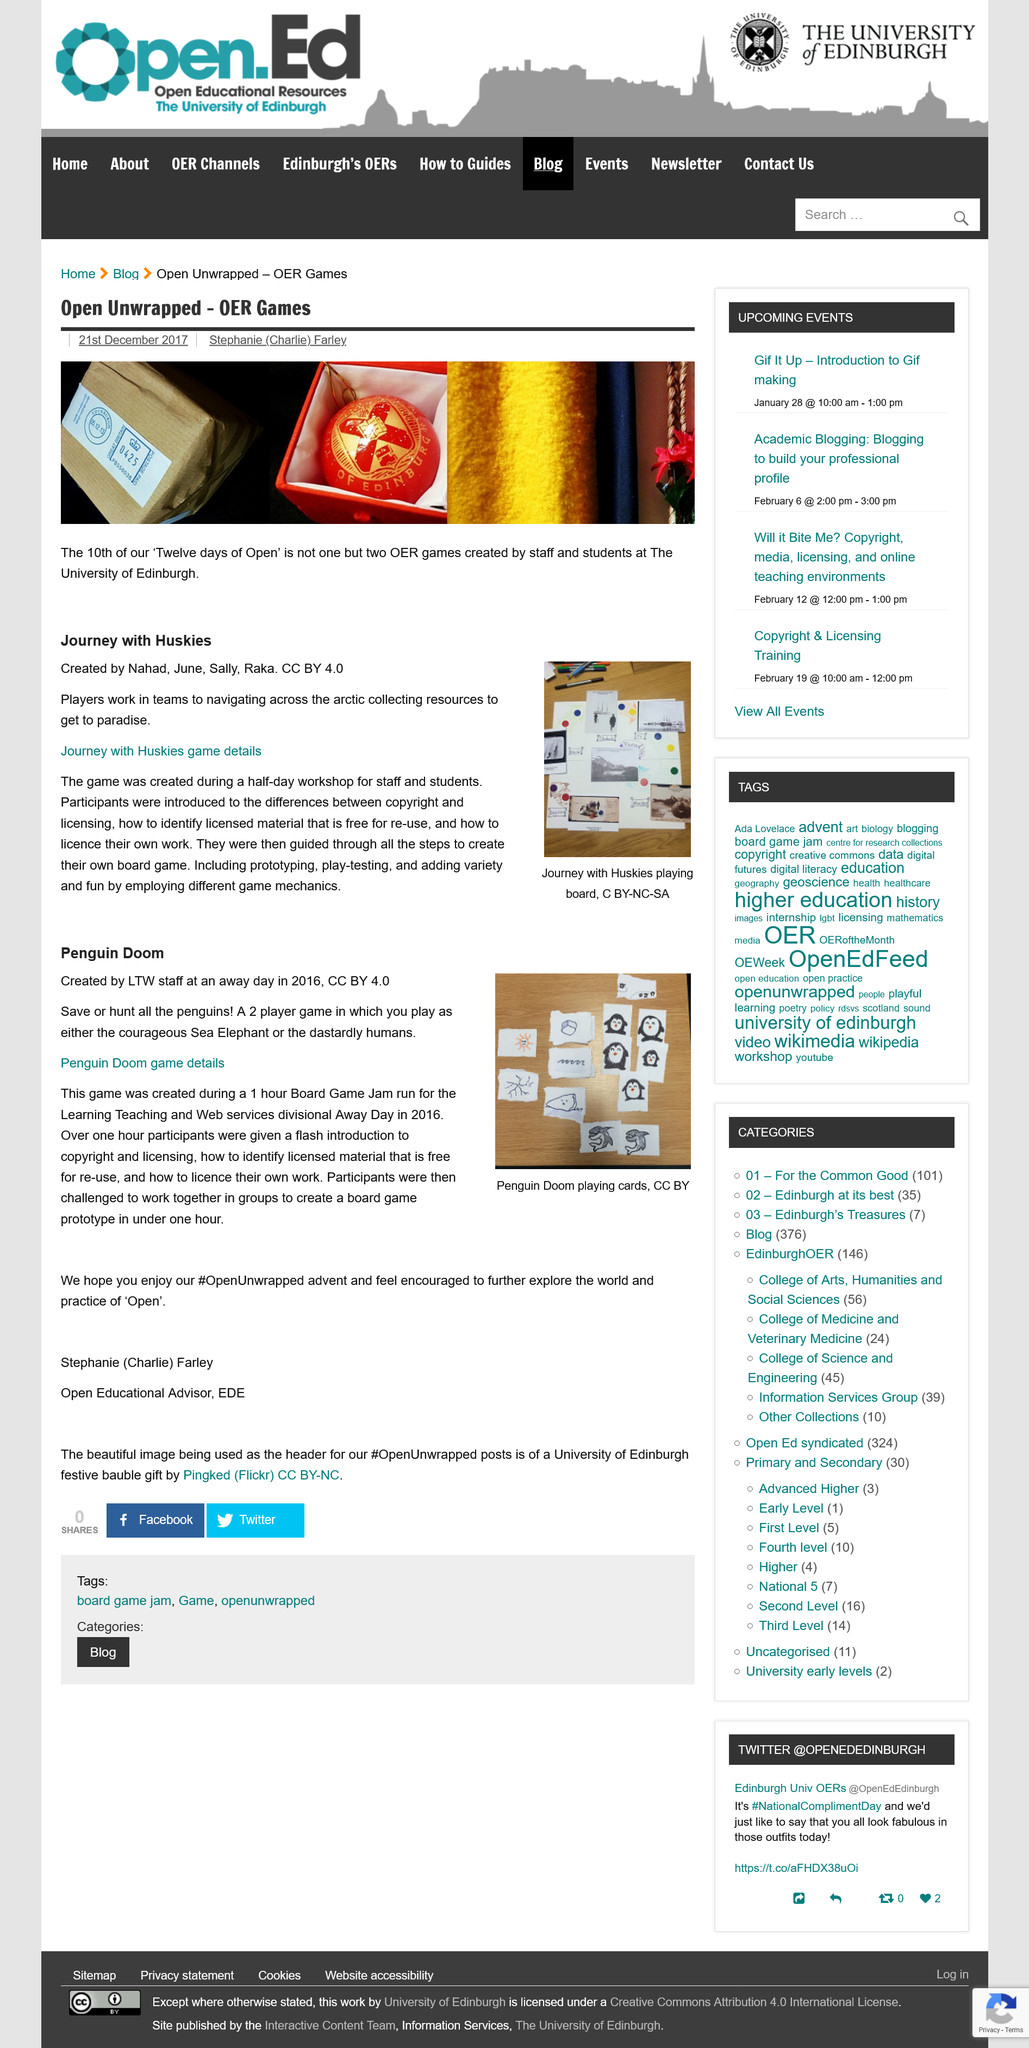Give some essential details in this illustration. The image depicts Penguin Doom engaging in the activity of playing cards. Penguin Doom, a board game designed during a 1 hour Jam for the Learning, Teaching and Web services divisional Away Day in 2016, was created through the collaborative efforts of its creators. Penguin Doom is a two-player game that allows for a maximum of two players to participate. The creators spent a half-day workshop producing the game, and it was created during that time. We, Nahad, June, Sally, and Raka, created the Journey with Huskies game during a workshop for staff and students. The game was developed to enhance our learning and engagement. 